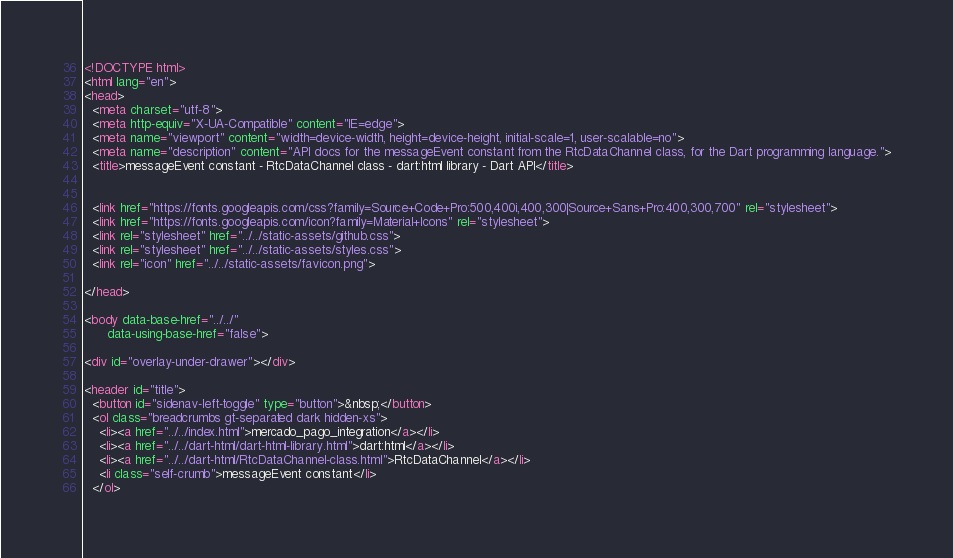<code> <loc_0><loc_0><loc_500><loc_500><_HTML_><!DOCTYPE html>
<html lang="en">
<head>
  <meta charset="utf-8">
  <meta http-equiv="X-UA-Compatible" content="IE=edge">
  <meta name="viewport" content="width=device-width, height=device-height, initial-scale=1, user-scalable=no">
  <meta name="description" content="API docs for the messageEvent constant from the RtcDataChannel class, for the Dart programming language.">
  <title>messageEvent constant - RtcDataChannel class - dart:html library - Dart API</title>

  
  <link href="https://fonts.googleapis.com/css?family=Source+Code+Pro:500,400i,400,300|Source+Sans+Pro:400,300,700" rel="stylesheet">
  <link href="https://fonts.googleapis.com/icon?family=Material+Icons" rel="stylesheet">
  <link rel="stylesheet" href="../../static-assets/github.css">
  <link rel="stylesheet" href="../../static-assets/styles.css">
  <link rel="icon" href="../../static-assets/favicon.png">

</head>

<body data-base-href="../../"
      data-using-base-href="false">

<div id="overlay-under-drawer"></div>

<header id="title">
  <button id="sidenav-left-toggle" type="button">&nbsp;</button>
  <ol class="breadcrumbs gt-separated dark hidden-xs">
    <li><a href="../../index.html">mercado_pago_integration</a></li>
    <li><a href="../../dart-html/dart-html-library.html">dart:html</a></li>
    <li><a href="../../dart-html/RtcDataChannel-class.html">RtcDataChannel</a></li>
    <li class="self-crumb">messageEvent constant</li>
  </ol></code> 